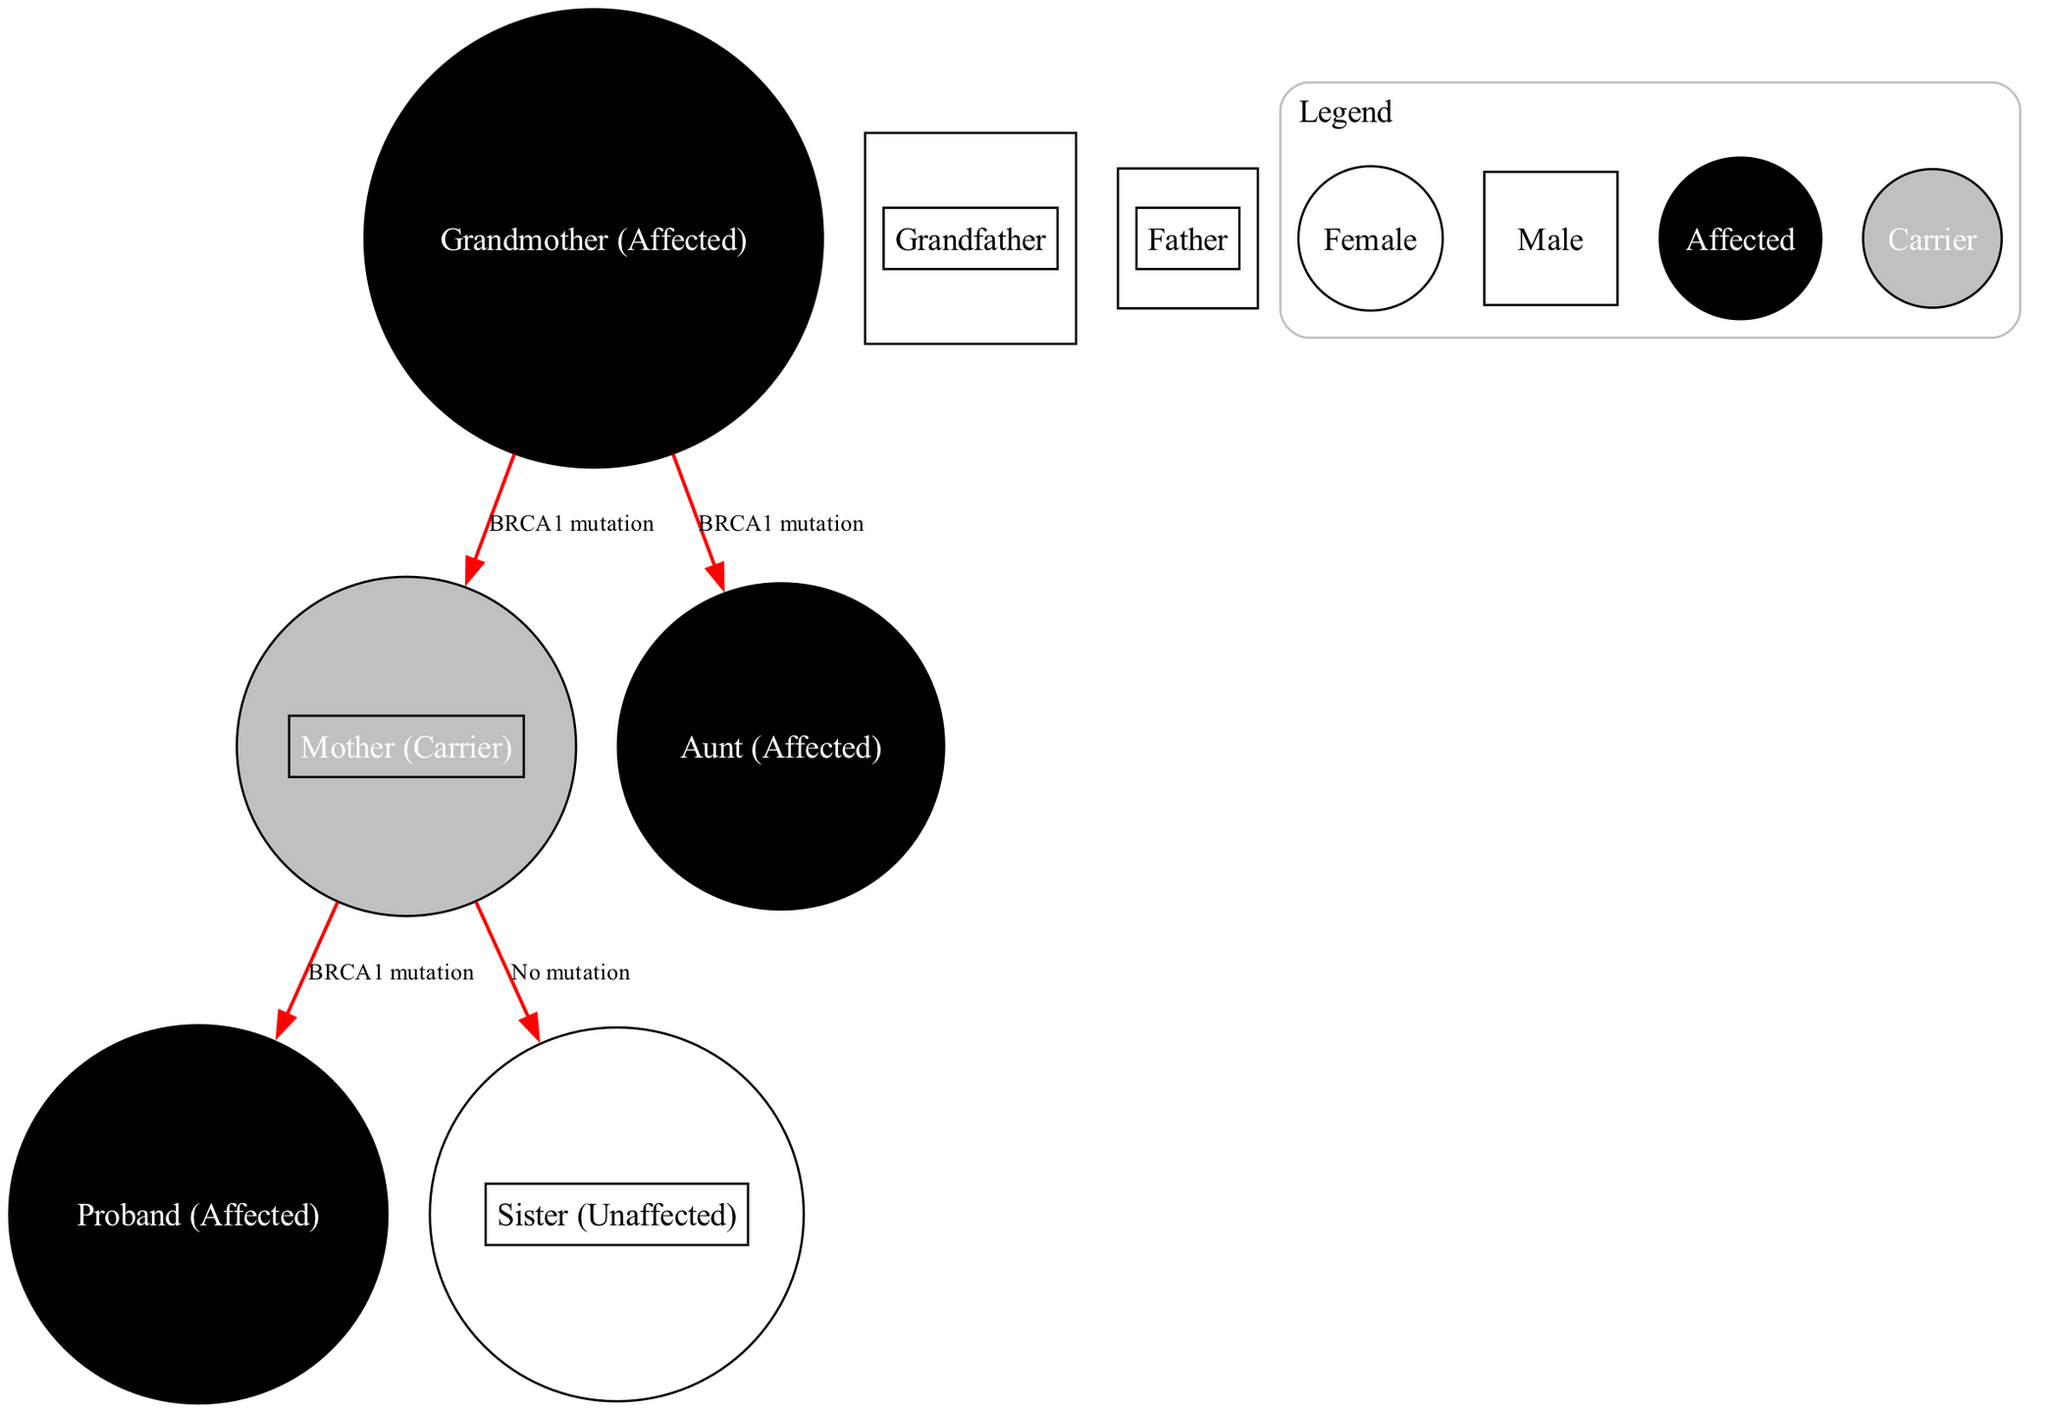What is the relationship between the grandmother and the proband? The grandmother is the maternal grandmother of the proband. The edges indicate a BRCA1 mutation inherited from the grandmother to the mother, which is passed on to the proband.
Answer: Maternal grandmother How many affected individuals are shown in the pedigree chart? The affected individuals in the chart are the grandmother, aunt, and proband. By counting the filled symbols, we identify three affected individuals.
Answer: Three Which individual is represented as a carrier in the diagram? The mother is labeled as a carrier, represented by a half-filled symbol, indicating she has the BRCA1 mutation but does not show the cancer phenotype.
Answer: Mother How many siblings does the proband have? The proband has one sibling, identified in the diagram as the sister, who is labeled as unaffected. There are two siblings shown in total (the proband and the sister).
Answer: One What genetic mutation is being tracked in this pedigree chart? The chart tracks the BRCA1 mutation's inheritance, as stated in the connecting edges labeled "BRCA1 mutation." This indicates the familial connection to ovarian cancer.
Answer: BRCA1 Is the sister affected by the BRCA1 mutation? The sister is marked as unaffected, which is confirmed by the label indicating "No mutation" between her and the mother. Therefore, she does not inherit the mutation.
Answer: No Who is the proband in the pedigree chart? The proband is the individual studied for genetic inheritance, indicated separately in the chart with the label "Proband (Affected)."
Answer: Proband What type of symbols are used to represent females in the diagram? Females are represented by circles in the pedigree chart, supported by the legend that explains the shapes for each gender.
Answer: Circles 